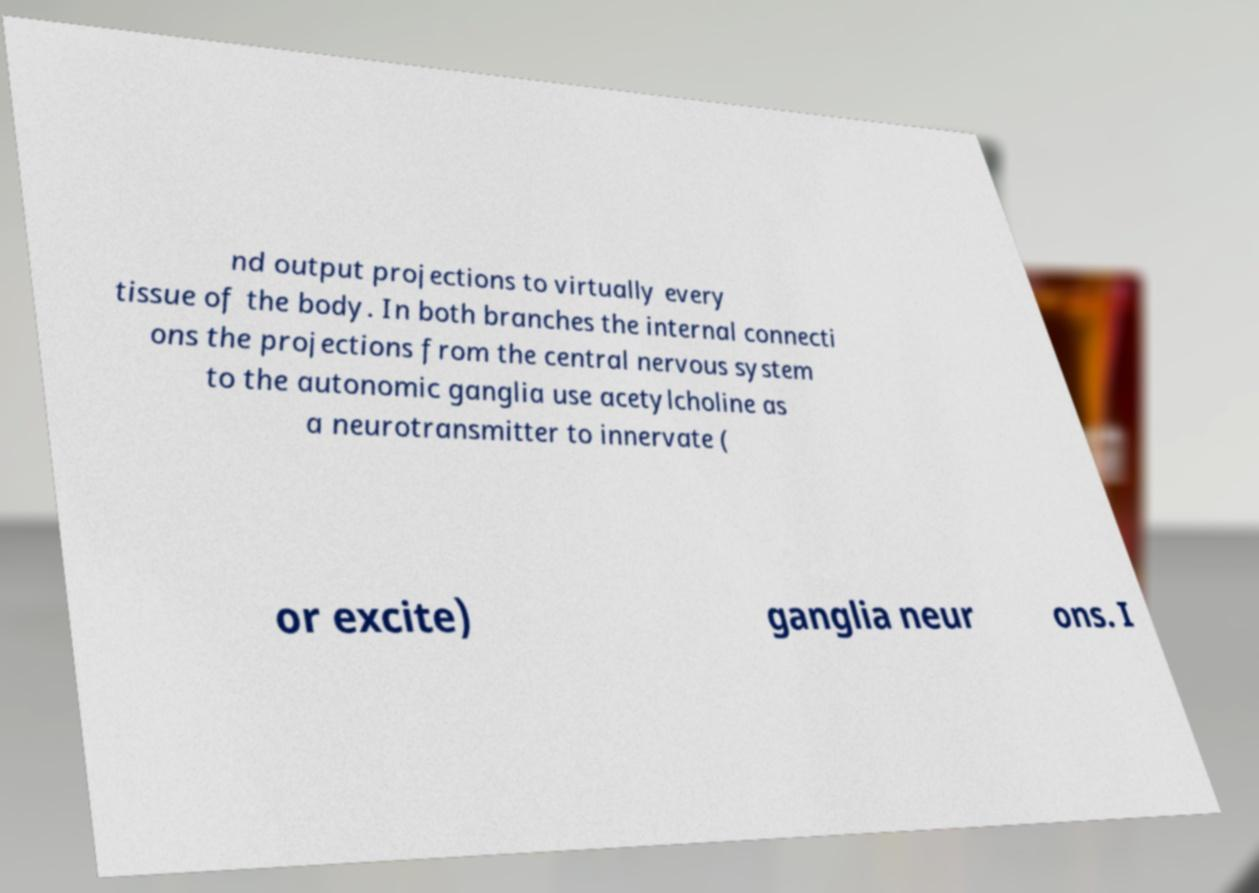What messages or text are displayed in this image? I need them in a readable, typed format. nd output projections to virtually every tissue of the body. In both branches the internal connecti ons the projections from the central nervous system to the autonomic ganglia use acetylcholine as a neurotransmitter to innervate ( or excite) ganglia neur ons. I 